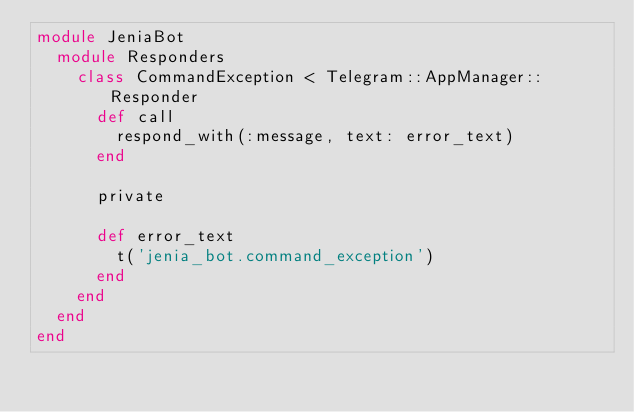Convert code to text. <code><loc_0><loc_0><loc_500><loc_500><_Ruby_>module JeniaBot
  module Responders
    class CommandException < Telegram::AppManager::Responder
      def call
        respond_with(:message, text: error_text)
      end

      private

      def error_text
        t('jenia_bot.command_exception')
      end
    end
  end
end
</code> 